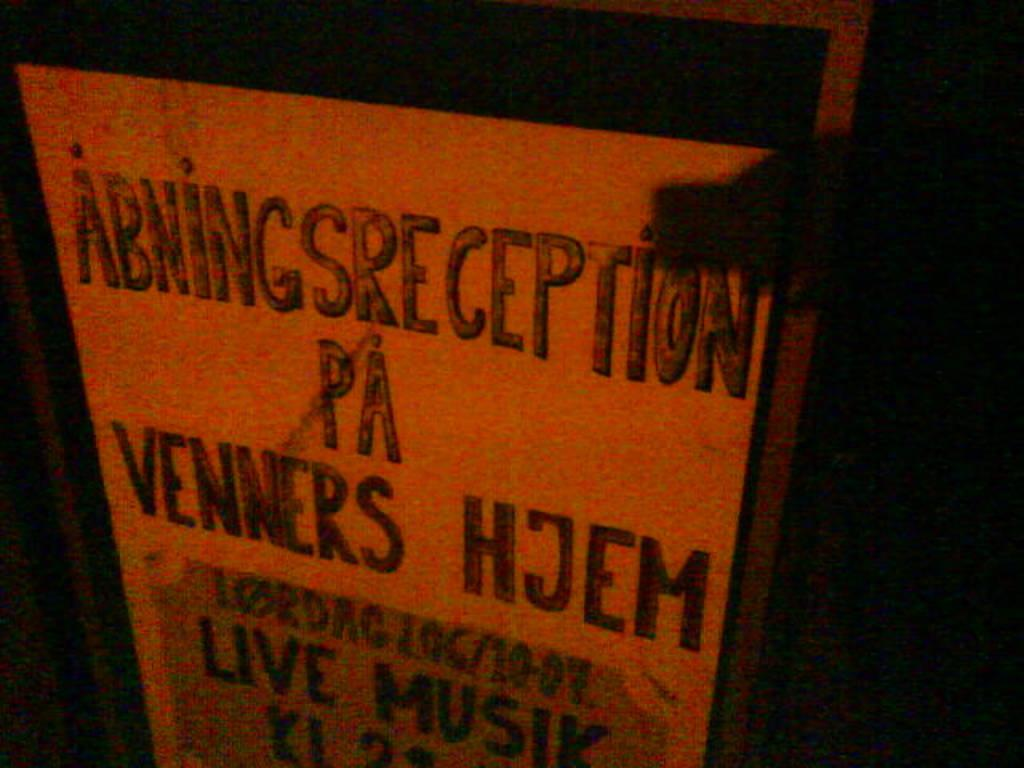<image>
Create a compact narrative representing the image presented. A sign says live musik towards the bottom. 